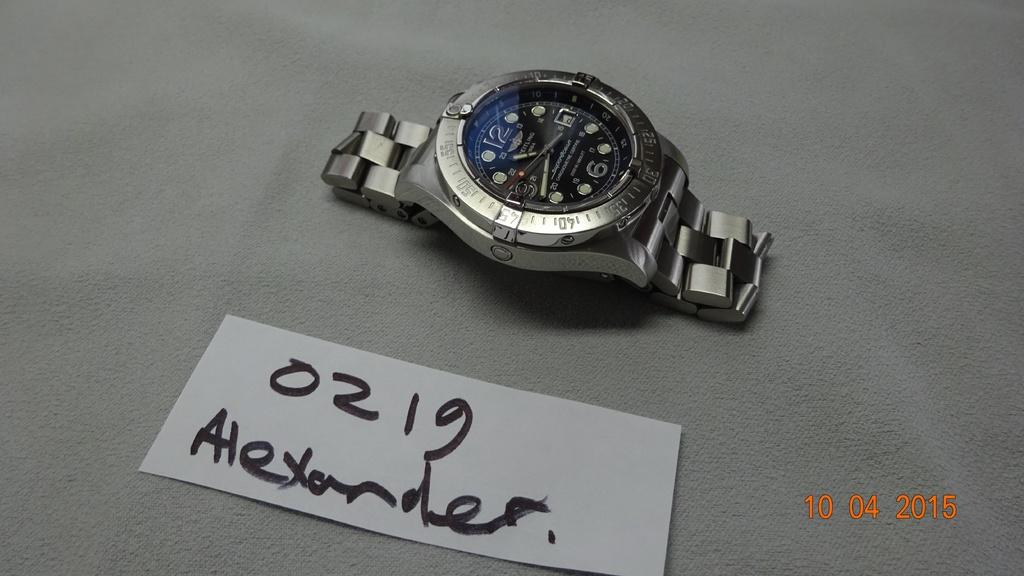What is present on the table in the image? There is a paper on the table in the image. What can be seen on the paper? There is text on the paper. What is located at the top of the image? There is a watch at the top of the image. Where is the date placed in the image? The date is at the bottom right of the image. What type of drain is visible in the image? There is no drain present in the image. Can you describe the tin used to hold the watch in the image? There is no tin present in the image; the watch is located at the top of the image. 